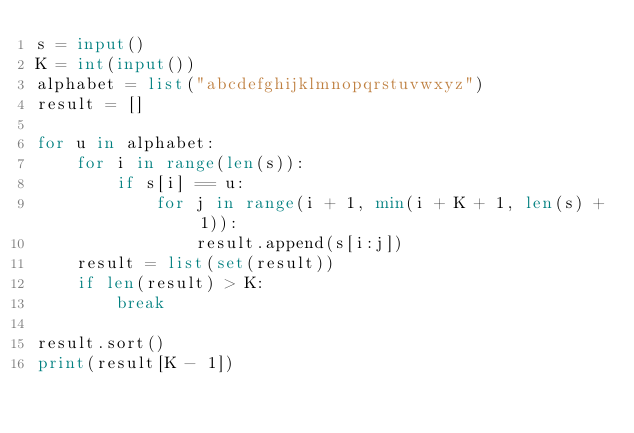Convert code to text. <code><loc_0><loc_0><loc_500><loc_500><_Python_>s = input()
K = int(input())
alphabet = list("abcdefghijklmnopqrstuvwxyz")
result = []

for u in alphabet:
    for i in range(len(s)):
        if s[i] == u:
            for j in range(i + 1, min(i + K + 1, len(s) + 1)):
                result.append(s[i:j])
    result = list(set(result))
    if len(result) > K:
        break

result.sort()
print(result[K - 1])
</code> 